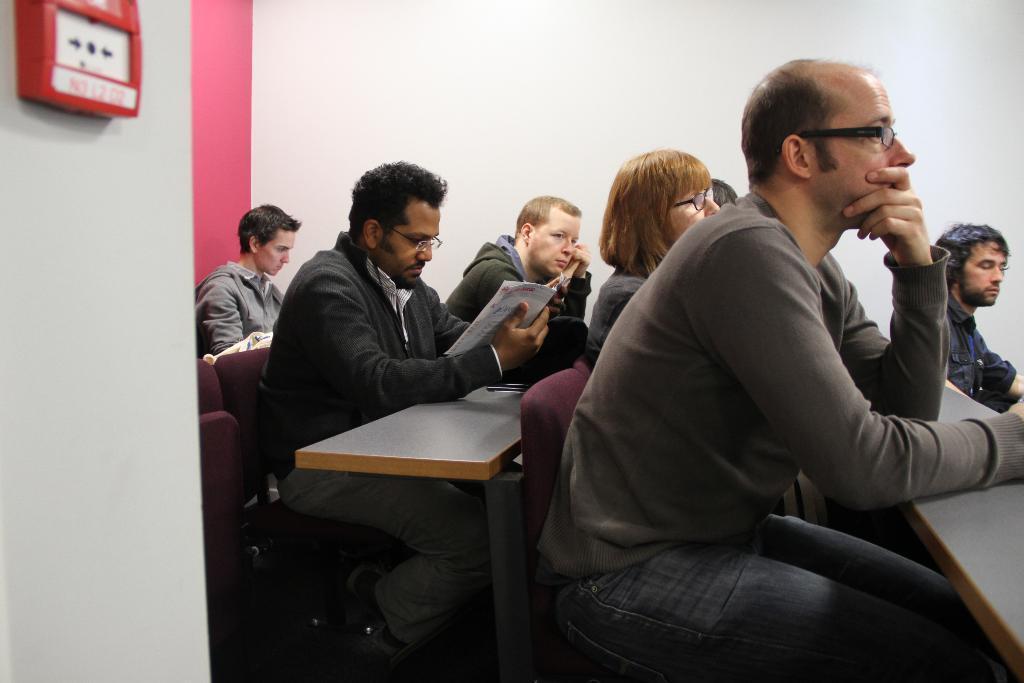In one or two sentences, can you explain what this image depicts? The image is taken in the room. The room is filled with tables and chairs. There are people sitting. On the left there is a fire alarm which is attached to the wall. 